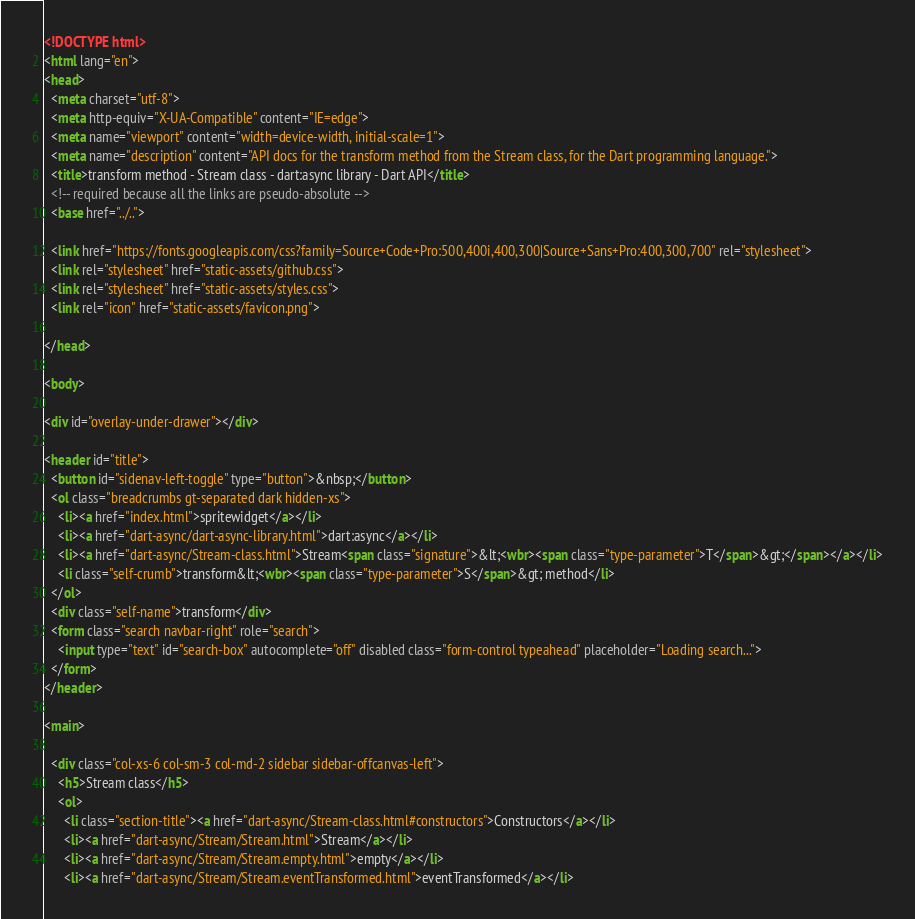Convert code to text. <code><loc_0><loc_0><loc_500><loc_500><_HTML_><!DOCTYPE html>
<html lang="en">
<head>
  <meta charset="utf-8">
  <meta http-equiv="X-UA-Compatible" content="IE=edge">
  <meta name="viewport" content="width=device-width, initial-scale=1">
  <meta name="description" content="API docs for the transform method from the Stream class, for the Dart programming language.">
  <title>transform method - Stream class - dart:async library - Dart API</title>
  <!-- required because all the links are pseudo-absolute -->
  <base href="../..">

  <link href="https://fonts.googleapis.com/css?family=Source+Code+Pro:500,400i,400,300|Source+Sans+Pro:400,300,700" rel="stylesheet">
  <link rel="stylesheet" href="static-assets/github.css">
  <link rel="stylesheet" href="static-assets/styles.css">
  <link rel="icon" href="static-assets/favicon.png">

</head>

<body>

<div id="overlay-under-drawer"></div>

<header id="title">
  <button id="sidenav-left-toggle" type="button">&nbsp;</button>
  <ol class="breadcrumbs gt-separated dark hidden-xs">
    <li><a href="index.html">spritewidget</a></li>
    <li><a href="dart-async/dart-async-library.html">dart:async</a></li>
    <li><a href="dart-async/Stream-class.html">Stream<span class="signature">&lt;<wbr><span class="type-parameter">T</span>&gt;</span></a></li>
    <li class="self-crumb">transform&lt;<wbr><span class="type-parameter">S</span>&gt; method</li>
  </ol>
  <div class="self-name">transform</div>
  <form class="search navbar-right" role="search">
    <input type="text" id="search-box" autocomplete="off" disabled class="form-control typeahead" placeholder="Loading search...">
  </form>
</header>

<main>

  <div class="col-xs-6 col-sm-3 col-md-2 sidebar sidebar-offcanvas-left">
    <h5>Stream class</h5>
    <ol>
      <li class="section-title"><a href="dart-async/Stream-class.html#constructors">Constructors</a></li>
      <li><a href="dart-async/Stream/Stream.html">Stream</a></li>
      <li><a href="dart-async/Stream/Stream.empty.html">empty</a></li>
      <li><a href="dart-async/Stream/Stream.eventTransformed.html">eventTransformed</a></li></code> 